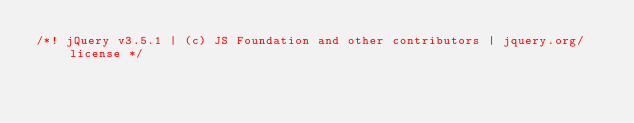<code> <loc_0><loc_0><loc_500><loc_500><_JavaScript_>/*! jQuery v3.5.1 | (c) JS Foundation and other contributors | jquery.org/license */</code> 